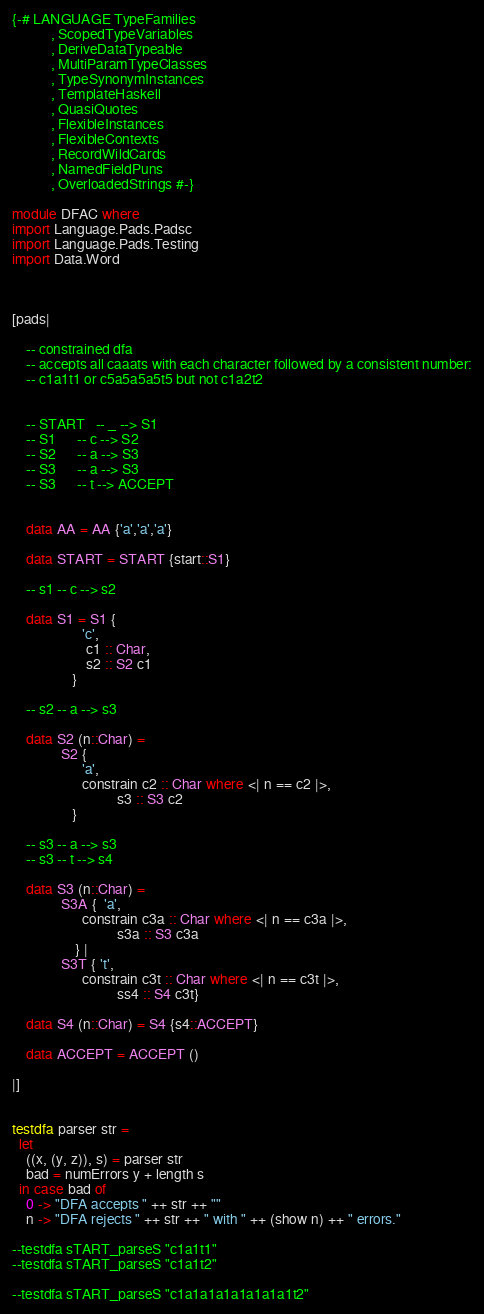<code> <loc_0><loc_0><loc_500><loc_500><_Haskell_>{-# LANGUAGE TypeFamilies
           , ScopedTypeVariables
           , DeriveDataTypeable
           , MultiParamTypeClasses
           , TypeSynonymInstances
           , TemplateHaskell
           , QuasiQuotes
           , FlexibleInstances
           , FlexibleContexts
           , RecordWildCards
           , NamedFieldPuns
           , OverloadedStrings #-}

module DFAC where
import Language.Pads.Padsc
import Language.Pads.Testing
import Data.Word



[pads|
    
    -- constrained dfa 
    -- accepts all caaats with each character followed by a consistent number:
    -- c1a1t1 or c5a5a5a5t5 but not c1a2t2


    -- START   -- _ --> S1
    -- S1      -- c --> S2
    -- S2      -- a --> S3
    -- S3      -- a --> S3
    -- S3      -- t --> ACCEPT


    data AA = AA {'a','a','a'}

    data START = START {start::S1}

    -- s1 -- c --> s2

    data S1 = S1 {
                    'c',
                     c1 :: Char,
                     s2 :: S2 c1
                 }

    -- s2 -- a --> s3

    data S2 (n::Char) = 
              S2 {  
                    'a',
                    constrain c2 :: Char where <| n == c2 |>,
                              s3 :: S3 c2
                 }

    -- s3 -- a --> s3
    -- s3 -- t --> s4

    data S3 (n::Char) = 
              S3A {  'a', 
                    constrain c3a :: Char where <| n == c3a |>,
                              s3a :: S3 c3a 
                  } |
              S3T { 't', 
                    constrain c3t :: Char where <| n == c3t |>,
                              ss4 :: S4 c3t}

    data S4 (n::Char) = S4 {s4::ACCEPT}

    data ACCEPT = ACCEPT ()

|]


testdfa parser str = 
  let 
    ((x, (y, z)), s) = parser str
    bad = numErrors y + length s       
  in case bad of 
    0 -> "DFA accepts " ++ str ++ ""
    n -> "DFA rejects " ++ str ++ " with " ++ (show n) ++ " errors."

--testdfa sTART_parseS "c1a1t1"
--testdfa sTART_parseS "c1a1t2"

--testdfa sTART_parseS "c1a1a1a1a1a1a1a1t2"</code> 